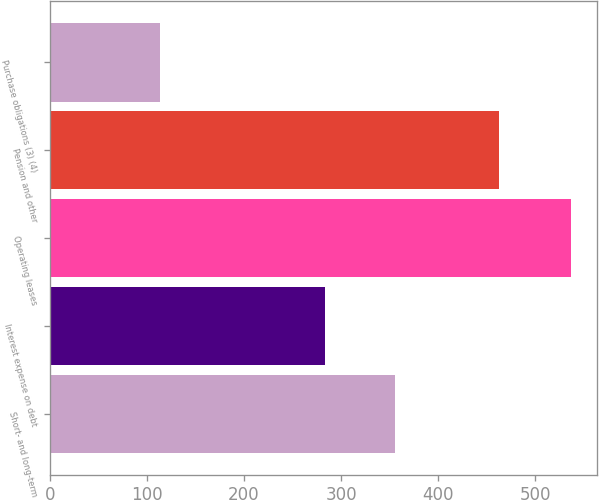<chart> <loc_0><loc_0><loc_500><loc_500><bar_chart><fcel>Short- and long-term<fcel>Interest expense on debt<fcel>Operating leases<fcel>Pension and other<fcel>Purchase obligations (3) (4)<nl><fcel>356<fcel>283<fcel>537<fcel>463<fcel>113<nl></chart> 